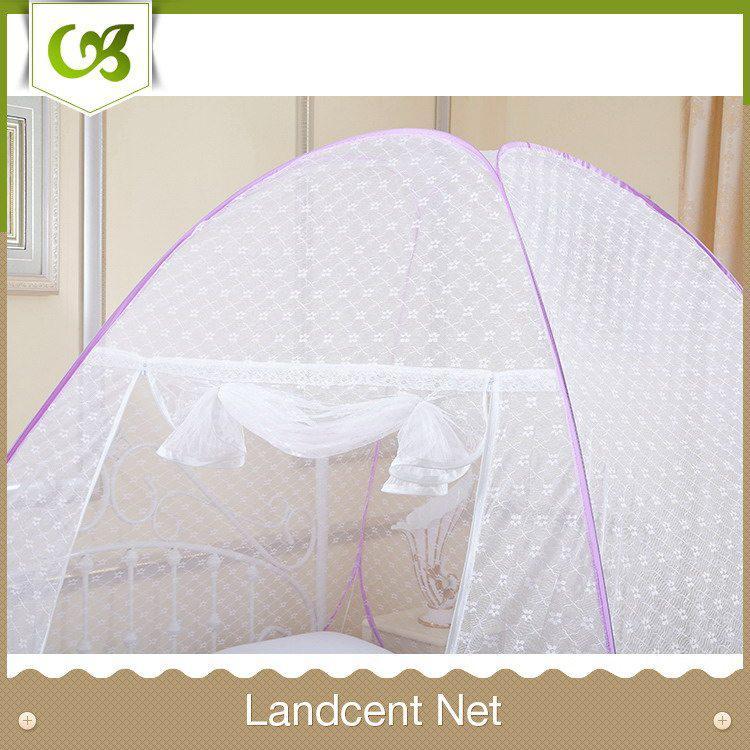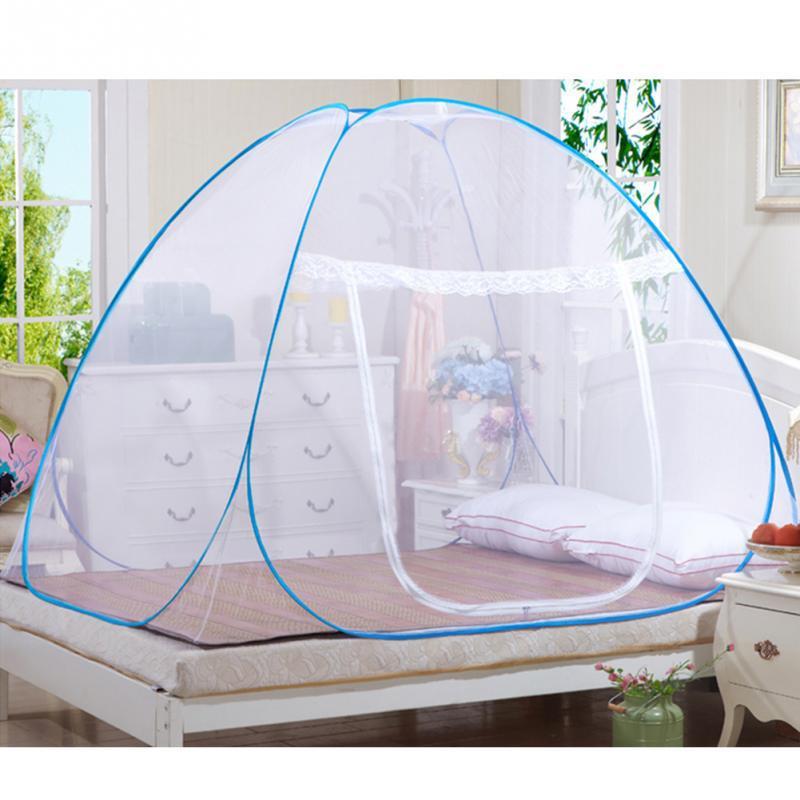The first image is the image on the left, the second image is the image on the right. Examine the images to the left and right. Is the description "At least one of the beds has a pink bedspread." accurate? Answer yes or no. No. 